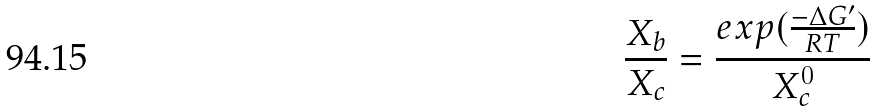Convert formula to latex. <formula><loc_0><loc_0><loc_500><loc_500>\frac { X _ { b } } { X _ { c } } = \frac { e x p ( \frac { - \Delta G ^ { \prime } } { R T } ) } { X _ { c } ^ { 0 } }</formula> 